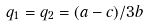<formula> <loc_0><loc_0><loc_500><loc_500>q _ { 1 } = q _ { 2 } = ( a - c ) / 3 b</formula> 